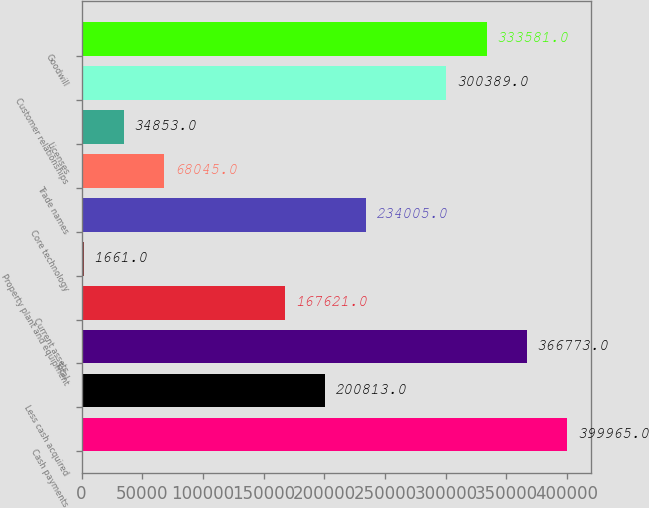Convert chart to OTSL. <chart><loc_0><loc_0><loc_500><loc_500><bar_chart><fcel>Cash payments<fcel>Less cash acquired<fcel>Total<fcel>Current assets<fcel>Property plant and equipment<fcel>Core technology<fcel>Trade names<fcel>Licenses<fcel>Customer relationships<fcel>Goodwill<nl><fcel>399965<fcel>200813<fcel>366773<fcel>167621<fcel>1661<fcel>234005<fcel>68045<fcel>34853<fcel>300389<fcel>333581<nl></chart> 